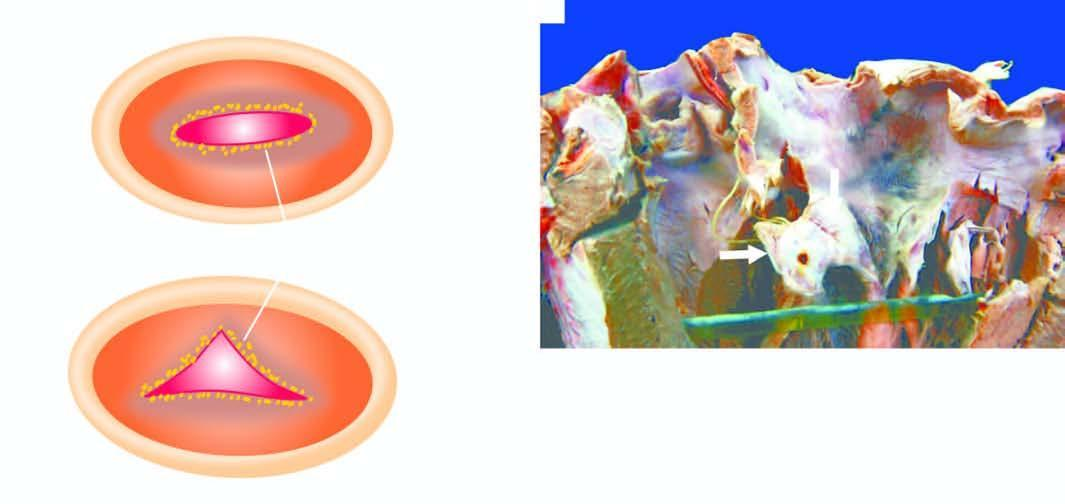what shows tiny firm granular vegetations?
Answer the question using a single word or phrase. Free surface and margin of the mitral valve 